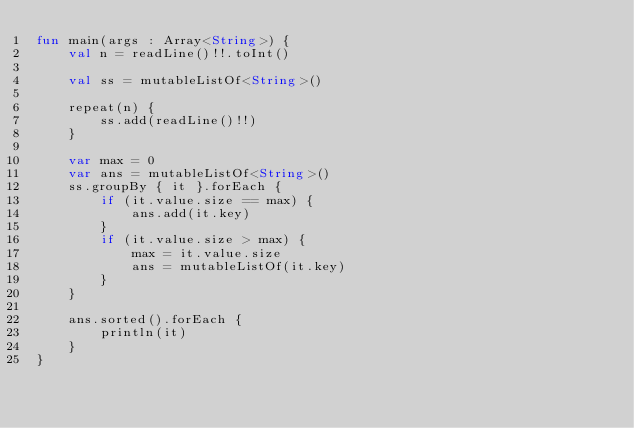<code> <loc_0><loc_0><loc_500><loc_500><_Kotlin_>fun main(args : Array<String>) {
    val n = readLine()!!.toInt()

    val ss = mutableListOf<String>()

    repeat(n) {
        ss.add(readLine()!!)
    }

    var max = 0
    var ans = mutableListOf<String>()
    ss.groupBy { it }.forEach {
        if (it.value.size == max) {
            ans.add(it.key)
        }
        if (it.value.size > max) {
            max = it.value.size
            ans = mutableListOf(it.key)
        }
    }

    ans.sorted().forEach {
        println(it)
    }
}</code> 